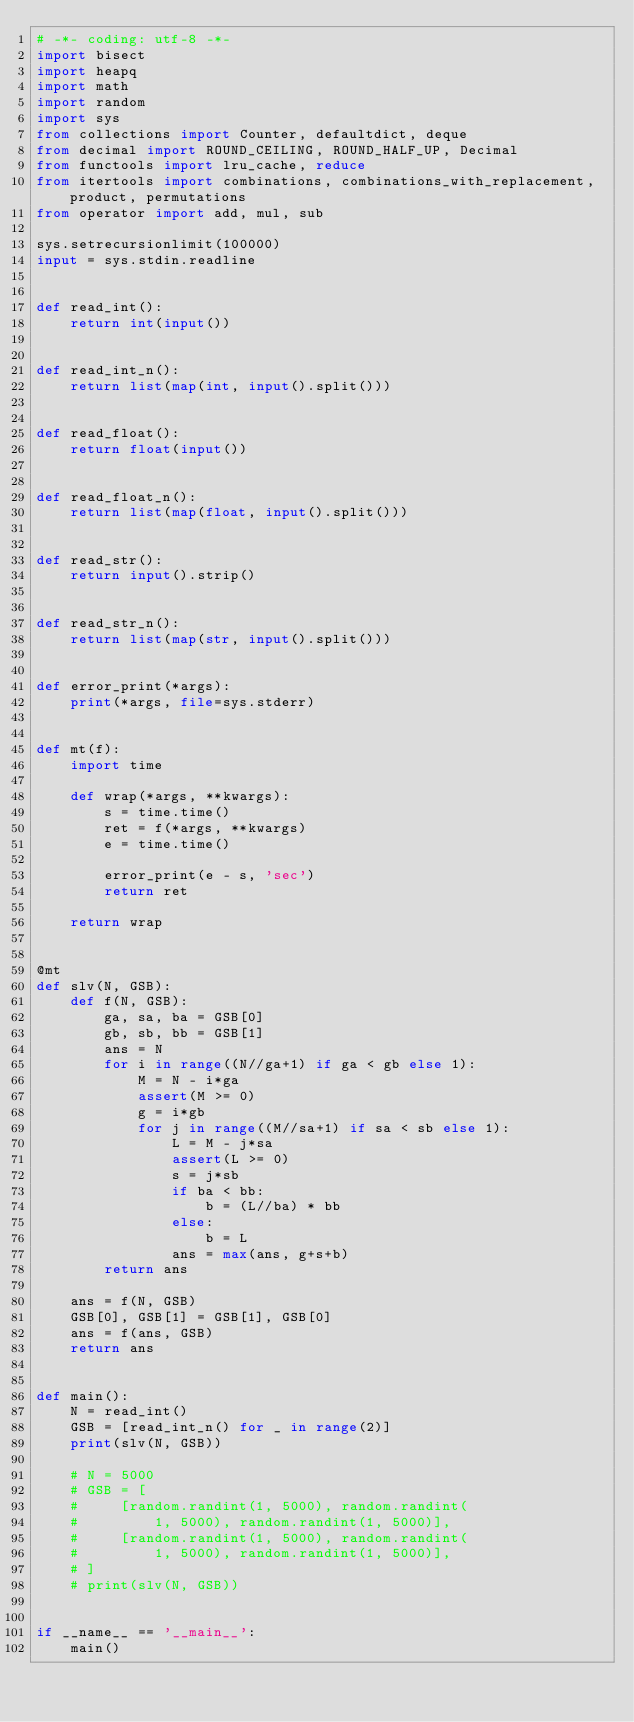Convert code to text. <code><loc_0><loc_0><loc_500><loc_500><_Python_># -*- coding: utf-8 -*-
import bisect
import heapq
import math
import random
import sys
from collections import Counter, defaultdict, deque
from decimal import ROUND_CEILING, ROUND_HALF_UP, Decimal
from functools import lru_cache, reduce
from itertools import combinations, combinations_with_replacement, product, permutations
from operator import add, mul, sub

sys.setrecursionlimit(100000)
input = sys.stdin.readline


def read_int():
    return int(input())


def read_int_n():
    return list(map(int, input().split()))


def read_float():
    return float(input())


def read_float_n():
    return list(map(float, input().split()))


def read_str():
    return input().strip()


def read_str_n():
    return list(map(str, input().split()))


def error_print(*args):
    print(*args, file=sys.stderr)


def mt(f):
    import time

    def wrap(*args, **kwargs):
        s = time.time()
        ret = f(*args, **kwargs)
        e = time.time()

        error_print(e - s, 'sec')
        return ret

    return wrap


@mt
def slv(N, GSB):
    def f(N, GSB):
        ga, sa, ba = GSB[0]
        gb, sb, bb = GSB[1]
        ans = N
        for i in range((N//ga+1) if ga < gb else 1):
            M = N - i*ga
            assert(M >= 0)
            g = i*gb
            for j in range((M//sa+1) if sa < sb else 1):
                L = M - j*sa
                assert(L >= 0)
                s = j*sb
                if ba < bb:
                    b = (L//ba) * bb
                else:
                    b = L
                ans = max(ans, g+s+b)
        return ans

    ans = f(N, GSB)
    GSB[0], GSB[1] = GSB[1], GSB[0]
    ans = f(ans, GSB)
    return ans


def main():
    N = read_int()
    GSB = [read_int_n() for _ in range(2)]
    print(slv(N, GSB))

    # N = 5000
    # GSB = [
    #     [random.randint(1, 5000), random.randint(
    #         1, 5000), random.randint(1, 5000)],
    #     [random.randint(1, 5000), random.randint(
    #         1, 5000), random.randint(1, 5000)],
    # ]
    # print(slv(N, GSB))


if __name__ == '__main__':
    main()
</code> 